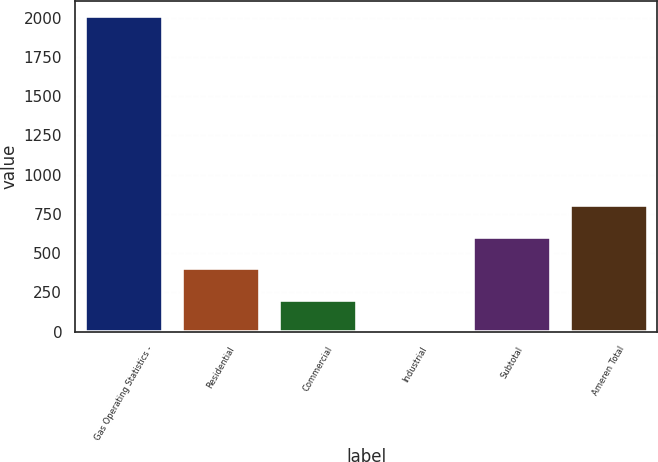<chart> <loc_0><loc_0><loc_500><loc_500><bar_chart><fcel>Gas Operating Statistics -<fcel>Residential<fcel>Commercial<fcel>Industrial<fcel>Subtotal<fcel>Ameren Total<nl><fcel>2008<fcel>402.4<fcel>201.7<fcel>1<fcel>603.1<fcel>803.8<nl></chart> 